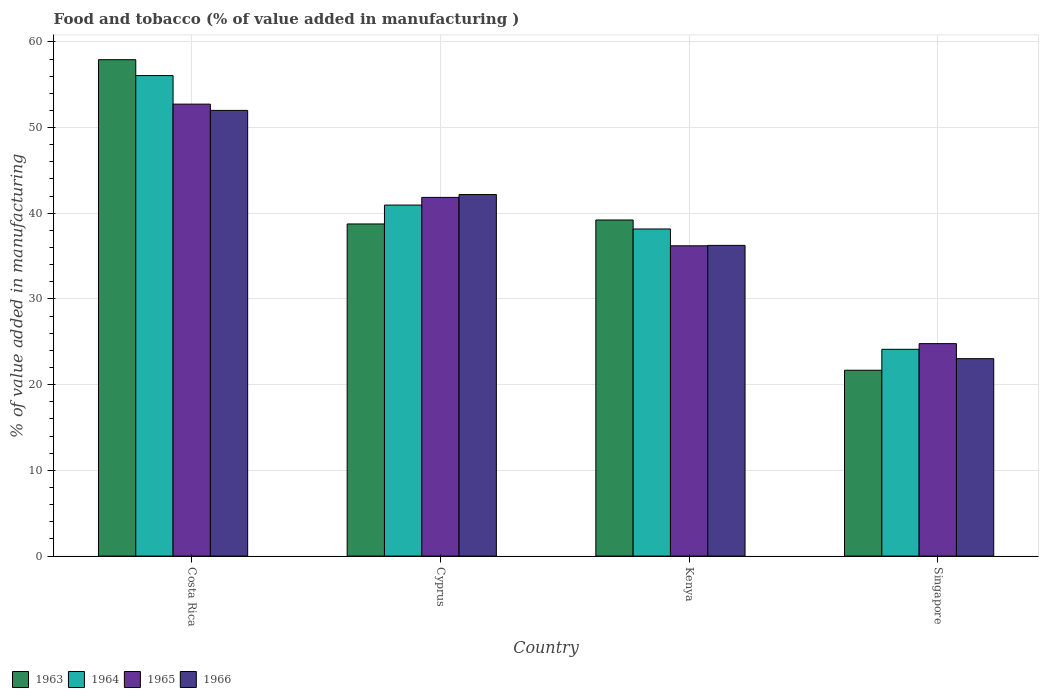How many groups of bars are there?
Make the answer very short. 4. Are the number of bars on each tick of the X-axis equal?
Your response must be concise. Yes. How many bars are there on the 2nd tick from the left?
Your answer should be compact. 4. How many bars are there on the 4th tick from the right?
Offer a terse response. 4. What is the value added in manufacturing food and tobacco in 1965 in Costa Rica?
Offer a terse response. 52.73. Across all countries, what is the maximum value added in manufacturing food and tobacco in 1963?
Your answer should be compact. 57.92. Across all countries, what is the minimum value added in manufacturing food and tobacco in 1965?
Offer a terse response. 24.79. In which country was the value added in manufacturing food and tobacco in 1966 minimum?
Offer a very short reply. Singapore. What is the total value added in manufacturing food and tobacco in 1963 in the graph?
Your response must be concise. 157.58. What is the difference between the value added in manufacturing food and tobacco in 1963 in Costa Rica and that in Cyprus?
Your response must be concise. 19.17. What is the difference between the value added in manufacturing food and tobacco in 1965 in Kenya and the value added in manufacturing food and tobacco in 1964 in Cyprus?
Provide a succinct answer. -4.75. What is the average value added in manufacturing food and tobacco in 1966 per country?
Offer a very short reply. 38.37. What is the difference between the value added in manufacturing food and tobacco of/in 1966 and value added in manufacturing food and tobacco of/in 1965 in Costa Rica?
Ensure brevity in your answer.  -0.73. What is the ratio of the value added in manufacturing food and tobacco in 1966 in Costa Rica to that in Kenya?
Provide a succinct answer. 1.43. Is the value added in manufacturing food and tobacco in 1963 in Costa Rica less than that in Kenya?
Offer a terse response. No. Is the difference between the value added in manufacturing food and tobacco in 1966 in Kenya and Singapore greater than the difference between the value added in manufacturing food and tobacco in 1965 in Kenya and Singapore?
Make the answer very short. Yes. What is the difference between the highest and the second highest value added in manufacturing food and tobacco in 1965?
Give a very brief answer. -10.88. What is the difference between the highest and the lowest value added in manufacturing food and tobacco in 1964?
Your answer should be compact. 31.94. In how many countries, is the value added in manufacturing food and tobacco in 1966 greater than the average value added in manufacturing food and tobacco in 1966 taken over all countries?
Provide a succinct answer. 2. Is the sum of the value added in manufacturing food and tobacco in 1964 in Cyprus and Singapore greater than the maximum value added in manufacturing food and tobacco in 1965 across all countries?
Your response must be concise. Yes. What does the 2nd bar from the left in Singapore represents?
Your answer should be very brief. 1964. What does the 1st bar from the right in Costa Rica represents?
Ensure brevity in your answer.  1966. How many countries are there in the graph?
Give a very brief answer. 4. Does the graph contain grids?
Make the answer very short. Yes. How are the legend labels stacked?
Provide a short and direct response. Horizontal. What is the title of the graph?
Offer a terse response. Food and tobacco (% of value added in manufacturing ). Does "1998" appear as one of the legend labels in the graph?
Provide a short and direct response. No. What is the label or title of the X-axis?
Keep it short and to the point. Country. What is the label or title of the Y-axis?
Keep it short and to the point. % of value added in manufacturing. What is the % of value added in manufacturing of 1963 in Costa Rica?
Give a very brief answer. 57.92. What is the % of value added in manufacturing of 1964 in Costa Rica?
Offer a very short reply. 56.07. What is the % of value added in manufacturing in 1965 in Costa Rica?
Your answer should be very brief. 52.73. What is the % of value added in manufacturing of 1966 in Costa Rica?
Offer a very short reply. 52. What is the % of value added in manufacturing of 1963 in Cyprus?
Give a very brief answer. 38.75. What is the % of value added in manufacturing of 1964 in Cyprus?
Ensure brevity in your answer.  40.96. What is the % of value added in manufacturing in 1965 in Cyprus?
Provide a short and direct response. 41.85. What is the % of value added in manufacturing of 1966 in Cyprus?
Provide a short and direct response. 42.19. What is the % of value added in manufacturing in 1963 in Kenya?
Offer a very short reply. 39.22. What is the % of value added in manufacturing in 1964 in Kenya?
Your answer should be very brief. 38.17. What is the % of value added in manufacturing of 1965 in Kenya?
Make the answer very short. 36.2. What is the % of value added in manufacturing of 1966 in Kenya?
Provide a short and direct response. 36.25. What is the % of value added in manufacturing in 1963 in Singapore?
Provide a succinct answer. 21.69. What is the % of value added in manufacturing in 1964 in Singapore?
Your response must be concise. 24.13. What is the % of value added in manufacturing in 1965 in Singapore?
Provide a succinct answer. 24.79. What is the % of value added in manufacturing in 1966 in Singapore?
Make the answer very short. 23.04. Across all countries, what is the maximum % of value added in manufacturing in 1963?
Offer a very short reply. 57.92. Across all countries, what is the maximum % of value added in manufacturing of 1964?
Provide a short and direct response. 56.07. Across all countries, what is the maximum % of value added in manufacturing in 1965?
Offer a very short reply. 52.73. Across all countries, what is the maximum % of value added in manufacturing of 1966?
Ensure brevity in your answer.  52. Across all countries, what is the minimum % of value added in manufacturing in 1963?
Your response must be concise. 21.69. Across all countries, what is the minimum % of value added in manufacturing in 1964?
Make the answer very short. 24.13. Across all countries, what is the minimum % of value added in manufacturing of 1965?
Offer a terse response. 24.79. Across all countries, what is the minimum % of value added in manufacturing in 1966?
Offer a very short reply. 23.04. What is the total % of value added in manufacturing of 1963 in the graph?
Provide a succinct answer. 157.58. What is the total % of value added in manufacturing in 1964 in the graph?
Give a very brief answer. 159.32. What is the total % of value added in manufacturing in 1965 in the graph?
Ensure brevity in your answer.  155.58. What is the total % of value added in manufacturing in 1966 in the graph?
Give a very brief answer. 153.48. What is the difference between the % of value added in manufacturing of 1963 in Costa Rica and that in Cyprus?
Your response must be concise. 19.17. What is the difference between the % of value added in manufacturing in 1964 in Costa Rica and that in Cyprus?
Offer a very short reply. 15.11. What is the difference between the % of value added in manufacturing in 1965 in Costa Rica and that in Cyprus?
Offer a very short reply. 10.88. What is the difference between the % of value added in manufacturing in 1966 in Costa Rica and that in Cyprus?
Make the answer very short. 9.82. What is the difference between the % of value added in manufacturing of 1963 in Costa Rica and that in Kenya?
Offer a terse response. 18.7. What is the difference between the % of value added in manufacturing in 1964 in Costa Rica and that in Kenya?
Provide a short and direct response. 17.9. What is the difference between the % of value added in manufacturing in 1965 in Costa Rica and that in Kenya?
Give a very brief answer. 16.53. What is the difference between the % of value added in manufacturing of 1966 in Costa Rica and that in Kenya?
Your answer should be compact. 15.75. What is the difference between the % of value added in manufacturing of 1963 in Costa Rica and that in Singapore?
Offer a terse response. 36.23. What is the difference between the % of value added in manufacturing in 1964 in Costa Rica and that in Singapore?
Your answer should be very brief. 31.94. What is the difference between the % of value added in manufacturing in 1965 in Costa Rica and that in Singapore?
Make the answer very short. 27.94. What is the difference between the % of value added in manufacturing of 1966 in Costa Rica and that in Singapore?
Your answer should be compact. 28.97. What is the difference between the % of value added in manufacturing in 1963 in Cyprus and that in Kenya?
Your response must be concise. -0.46. What is the difference between the % of value added in manufacturing in 1964 in Cyprus and that in Kenya?
Provide a short and direct response. 2.79. What is the difference between the % of value added in manufacturing in 1965 in Cyprus and that in Kenya?
Ensure brevity in your answer.  5.65. What is the difference between the % of value added in manufacturing in 1966 in Cyprus and that in Kenya?
Your answer should be compact. 5.93. What is the difference between the % of value added in manufacturing in 1963 in Cyprus and that in Singapore?
Your answer should be very brief. 17.07. What is the difference between the % of value added in manufacturing in 1964 in Cyprus and that in Singapore?
Your answer should be compact. 16.83. What is the difference between the % of value added in manufacturing of 1965 in Cyprus and that in Singapore?
Keep it short and to the point. 17.06. What is the difference between the % of value added in manufacturing of 1966 in Cyprus and that in Singapore?
Keep it short and to the point. 19.15. What is the difference between the % of value added in manufacturing of 1963 in Kenya and that in Singapore?
Keep it short and to the point. 17.53. What is the difference between the % of value added in manufacturing of 1964 in Kenya and that in Singapore?
Your answer should be compact. 14.04. What is the difference between the % of value added in manufacturing of 1965 in Kenya and that in Singapore?
Make the answer very short. 11.41. What is the difference between the % of value added in manufacturing of 1966 in Kenya and that in Singapore?
Your answer should be compact. 13.22. What is the difference between the % of value added in manufacturing of 1963 in Costa Rica and the % of value added in manufacturing of 1964 in Cyprus?
Provide a succinct answer. 16.96. What is the difference between the % of value added in manufacturing in 1963 in Costa Rica and the % of value added in manufacturing in 1965 in Cyprus?
Make the answer very short. 16.07. What is the difference between the % of value added in manufacturing of 1963 in Costa Rica and the % of value added in manufacturing of 1966 in Cyprus?
Give a very brief answer. 15.73. What is the difference between the % of value added in manufacturing of 1964 in Costa Rica and the % of value added in manufacturing of 1965 in Cyprus?
Provide a succinct answer. 14.21. What is the difference between the % of value added in manufacturing in 1964 in Costa Rica and the % of value added in manufacturing in 1966 in Cyprus?
Offer a very short reply. 13.88. What is the difference between the % of value added in manufacturing of 1965 in Costa Rica and the % of value added in manufacturing of 1966 in Cyprus?
Give a very brief answer. 10.55. What is the difference between the % of value added in manufacturing of 1963 in Costa Rica and the % of value added in manufacturing of 1964 in Kenya?
Make the answer very short. 19.75. What is the difference between the % of value added in manufacturing of 1963 in Costa Rica and the % of value added in manufacturing of 1965 in Kenya?
Your answer should be compact. 21.72. What is the difference between the % of value added in manufacturing of 1963 in Costa Rica and the % of value added in manufacturing of 1966 in Kenya?
Provide a succinct answer. 21.67. What is the difference between the % of value added in manufacturing of 1964 in Costa Rica and the % of value added in manufacturing of 1965 in Kenya?
Offer a terse response. 19.86. What is the difference between the % of value added in manufacturing of 1964 in Costa Rica and the % of value added in manufacturing of 1966 in Kenya?
Your answer should be very brief. 19.81. What is the difference between the % of value added in manufacturing of 1965 in Costa Rica and the % of value added in manufacturing of 1966 in Kenya?
Offer a terse response. 16.48. What is the difference between the % of value added in manufacturing of 1963 in Costa Rica and the % of value added in manufacturing of 1964 in Singapore?
Give a very brief answer. 33.79. What is the difference between the % of value added in manufacturing of 1963 in Costa Rica and the % of value added in manufacturing of 1965 in Singapore?
Provide a short and direct response. 33.13. What is the difference between the % of value added in manufacturing of 1963 in Costa Rica and the % of value added in manufacturing of 1966 in Singapore?
Give a very brief answer. 34.88. What is the difference between the % of value added in manufacturing in 1964 in Costa Rica and the % of value added in manufacturing in 1965 in Singapore?
Keep it short and to the point. 31.28. What is the difference between the % of value added in manufacturing in 1964 in Costa Rica and the % of value added in manufacturing in 1966 in Singapore?
Offer a terse response. 33.03. What is the difference between the % of value added in manufacturing in 1965 in Costa Rica and the % of value added in manufacturing in 1966 in Singapore?
Provide a short and direct response. 29.7. What is the difference between the % of value added in manufacturing of 1963 in Cyprus and the % of value added in manufacturing of 1964 in Kenya?
Ensure brevity in your answer.  0.59. What is the difference between the % of value added in manufacturing of 1963 in Cyprus and the % of value added in manufacturing of 1965 in Kenya?
Keep it short and to the point. 2.55. What is the difference between the % of value added in manufacturing in 1963 in Cyprus and the % of value added in manufacturing in 1966 in Kenya?
Provide a short and direct response. 2.5. What is the difference between the % of value added in manufacturing of 1964 in Cyprus and the % of value added in manufacturing of 1965 in Kenya?
Offer a terse response. 4.75. What is the difference between the % of value added in manufacturing of 1964 in Cyprus and the % of value added in manufacturing of 1966 in Kenya?
Keep it short and to the point. 4.7. What is the difference between the % of value added in manufacturing of 1965 in Cyprus and the % of value added in manufacturing of 1966 in Kenya?
Provide a short and direct response. 5.6. What is the difference between the % of value added in manufacturing in 1963 in Cyprus and the % of value added in manufacturing in 1964 in Singapore?
Ensure brevity in your answer.  14.63. What is the difference between the % of value added in manufacturing in 1963 in Cyprus and the % of value added in manufacturing in 1965 in Singapore?
Your answer should be compact. 13.96. What is the difference between the % of value added in manufacturing in 1963 in Cyprus and the % of value added in manufacturing in 1966 in Singapore?
Your response must be concise. 15.72. What is the difference between the % of value added in manufacturing of 1964 in Cyprus and the % of value added in manufacturing of 1965 in Singapore?
Offer a terse response. 16.17. What is the difference between the % of value added in manufacturing in 1964 in Cyprus and the % of value added in manufacturing in 1966 in Singapore?
Your answer should be very brief. 17.92. What is the difference between the % of value added in manufacturing of 1965 in Cyprus and the % of value added in manufacturing of 1966 in Singapore?
Offer a terse response. 18.82. What is the difference between the % of value added in manufacturing of 1963 in Kenya and the % of value added in manufacturing of 1964 in Singapore?
Ensure brevity in your answer.  15.09. What is the difference between the % of value added in manufacturing in 1963 in Kenya and the % of value added in manufacturing in 1965 in Singapore?
Provide a succinct answer. 14.43. What is the difference between the % of value added in manufacturing in 1963 in Kenya and the % of value added in manufacturing in 1966 in Singapore?
Make the answer very short. 16.18. What is the difference between the % of value added in manufacturing in 1964 in Kenya and the % of value added in manufacturing in 1965 in Singapore?
Keep it short and to the point. 13.38. What is the difference between the % of value added in manufacturing of 1964 in Kenya and the % of value added in manufacturing of 1966 in Singapore?
Your answer should be very brief. 15.13. What is the difference between the % of value added in manufacturing in 1965 in Kenya and the % of value added in manufacturing in 1966 in Singapore?
Your answer should be compact. 13.17. What is the average % of value added in manufacturing in 1963 per country?
Your answer should be very brief. 39.39. What is the average % of value added in manufacturing in 1964 per country?
Make the answer very short. 39.83. What is the average % of value added in manufacturing of 1965 per country?
Offer a very short reply. 38.9. What is the average % of value added in manufacturing of 1966 per country?
Provide a succinct answer. 38.37. What is the difference between the % of value added in manufacturing of 1963 and % of value added in manufacturing of 1964 in Costa Rica?
Make the answer very short. 1.85. What is the difference between the % of value added in manufacturing in 1963 and % of value added in manufacturing in 1965 in Costa Rica?
Offer a terse response. 5.19. What is the difference between the % of value added in manufacturing of 1963 and % of value added in manufacturing of 1966 in Costa Rica?
Keep it short and to the point. 5.92. What is the difference between the % of value added in manufacturing of 1964 and % of value added in manufacturing of 1965 in Costa Rica?
Give a very brief answer. 3.33. What is the difference between the % of value added in manufacturing of 1964 and % of value added in manufacturing of 1966 in Costa Rica?
Make the answer very short. 4.06. What is the difference between the % of value added in manufacturing of 1965 and % of value added in manufacturing of 1966 in Costa Rica?
Ensure brevity in your answer.  0.73. What is the difference between the % of value added in manufacturing in 1963 and % of value added in manufacturing in 1964 in Cyprus?
Offer a very short reply. -2.2. What is the difference between the % of value added in manufacturing of 1963 and % of value added in manufacturing of 1965 in Cyprus?
Ensure brevity in your answer.  -3.1. What is the difference between the % of value added in manufacturing in 1963 and % of value added in manufacturing in 1966 in Cyprus?
Provide a short and direct response. -3.43. What is the difference between the % of value added in manufacturing of 1964 and % of value added in manufacturing of 1965 in Cyprus?
Offer a terse response. -0.9. What is the difference between the % of value added in manufacturing of 1964 and % of value added in manufacturing of 1966 in Cyprus?
Ensure brevity in your answer.  -1.23. What is the difference between the % of value added in manufacturing in 1963 and % of value added in manufacturing in 1964 in Kenya?
Provide a succinct answer. 1.05. What is the difference between the % of value added in manufacturing in 1963 and % of value added in manufacturing in 1965 in Kenya?
Make the answer very short. 3.01. What is the difference between the % of value added in manufacturing in 1963 and % of value added in manufacturing in 1966 in Kenya?
Your answer should be compact. 2.96. What is the difference between the % of value added in manufacturing in 1964 and % of value added in manufacturing in 1965 in Kenya?
Offer a terse response. 1.96. What is the difference between the % of value added in manufacturing of 1964 and % of value added in manufacturing of 1966 in Kenya?
Offer a very short reply. 1.91. What is the difference between the % of value added in manufacturing of 1965 and % of value added in manufacturing of 1966 in Kenya?
Provide a short and direct response. -0.05. What is the difference between the % of value added in manufacturing in 1963 and % of value added in manufacturing in 1964 in Singapore?
Keep it short and to the point. -2.44. What is the difference between the % of value added in manufacturing in 1963 and % of value added in manufacturing in 1965 in Singapore?
Provide a short and direct response. -3.1. What is the difference between the % of value added in manufacturing in 1963 and % of value added in manufacturing in 1966 in Singapore?
Provide a succinct answer. -1.35. What is the difference between the % of value added in manufacturing of 1964 and % of value added in manufacturing of 1965 in Singapore?
Keep it short and to the point. -0.66. What is the difference between the % of value added in manufacturing of 1964 and % of value added in manufacturing of 1966 in Singapore?
Offer a very short reply. 1.09. What is the difference between the % of value added in manufacturing of 1965 and % of value added in manufacturing of 1966 in Singapore?
Offer a terse response. 1.75. What is the ratio of the % of value added in manufacturing of 1963 in Costa Rica to that in Cyprus?
Keep it short and to the point. 1.49. What is the ratio of the % of value added in manufacturing in 1964 in Costa Rica to that in Cyprus?
Offer a terse response. 1.37. What is the ratio of the % of value added in manufacturing in 1965 in Costa Rica to that in Cyprus?
Make the answer very short. 1.26. What is the ratio of the % of value added in manufacturing of 1966 in Costa Rica to that in Cyprus?
Your response must be concise. 1.23. What is the ratio of the % of value added in manufacturing of 1963 in Costa Rica to that in Kenya?
Your response must be concise. 1.48. What is the ratio of the % of value added in manufacturing in 1964 in Costa Rica to that in Kenya?
Your response must be concise. 1.47. What is the ratio of the % of value added in manufacturing of 1965 in Costa Rica to that in Kenya?
Ensure brevity in your answer.  1.46. What is the ratio of the % of value added in manufacturing in 1966 in Costa Rica to that in Kenya?
Offer a very short reply. 1.43. What is the ratio of the % of value added in manufacturing of 1963 in Costa Rica to that in Singapore?
Ensure brevity in your answer.  2.67. What is the ratio of the % of value added in manufacturing of 1964 in Costa Rica to that in Singapore?
Provide a succinct answer. 2.32. What is the ratio of the % of value added in manufacturing of 1965 in Costa Rica to that in Singapore?
Make the answer very short. 2.13. What is the ratio of the % of value added in manufacturing of 1966 in Costa Rica to that in Singapore?
Provide a succinct answer. 2.26. What is the ratio of the % of value added in manufacturing of 1964 in Cyprus to that in Kenya?
Give a very brief answer. 1.07. What is the ratio of the % of value added in manufacturing of 1965 in Cyprus to that in Kenya?
Keep it short and to the point. 1.16. What is the ratio of the % of value added in manufacturing of 1966 in Cyprus to that in Kenya?
Make the answer very short. 1.16. What is the ratio of the % of value added in manufacturing in 1963 in Cyprus to that in Singapore?
Give a very brief answer. 1.79. What is the ratio of the % of value added in manufacturing in 1964 in Cyprus to that in Singapore?
Provide a short and direct response. 1.7. What is the ratio of the % of value added in manufacturing in 1965 in Cyprus to that in Singapore?
Your response must be concise. 1.69. What is the ratio of the % of value added in manufacturing of 1966 in Cyprus to that in Singapore?
Give a very brief answer. 1.83. What is the ratio of the % of value added in manufacturing of 1963 in Kenya to that in Singapore?
Your answer should be compact. 1.81. What is the ratio of the % of value added in manufacturing of 1964 in Kenya to that in Singapore?
Your response must be concise. 1.58. What is the ratio of the % of value added in manufacturing of 1965 in Kenya to that in Singapore?
Keep it short and to the point. 1.46. What is the ratio of the % of value added in manufacturing in 1966 in Kenya to that in Singapore?
Provide a succinct answer. 1.57. What is the difference between the highest and the second highest % of value added in manufacturing in 1963?
Keep it short and to the point. 18.7. What is the difference between the highest and the second highest % of value added in manufacturing in 1964?
Your answer should be very brief. 15.11. What is the difference between the highest and the second highest % of value added in manufacturing in 1965?
Offer a terse response. 10.88. What is the difference between the highest and the second highest % of value added in manufacturing of 1966?
Your response must be concise. 9.82. What is the difference between the highest and the lowest % of value added in manufacturing in 1963?
Offer a terse response. 36.23. What is the difference between the highest and the lowest % of value added in manufacturing in 1964?
Ensure brevity in your answer.  31.94. What is the difference between the highest and the lowest % of value added in manufacturing of 1965?
Your response must be concise. 27.94. What is the difference between the highest and the lowest % of value added in manufacturing in 1966?
Your response must be concise. 28.97. 